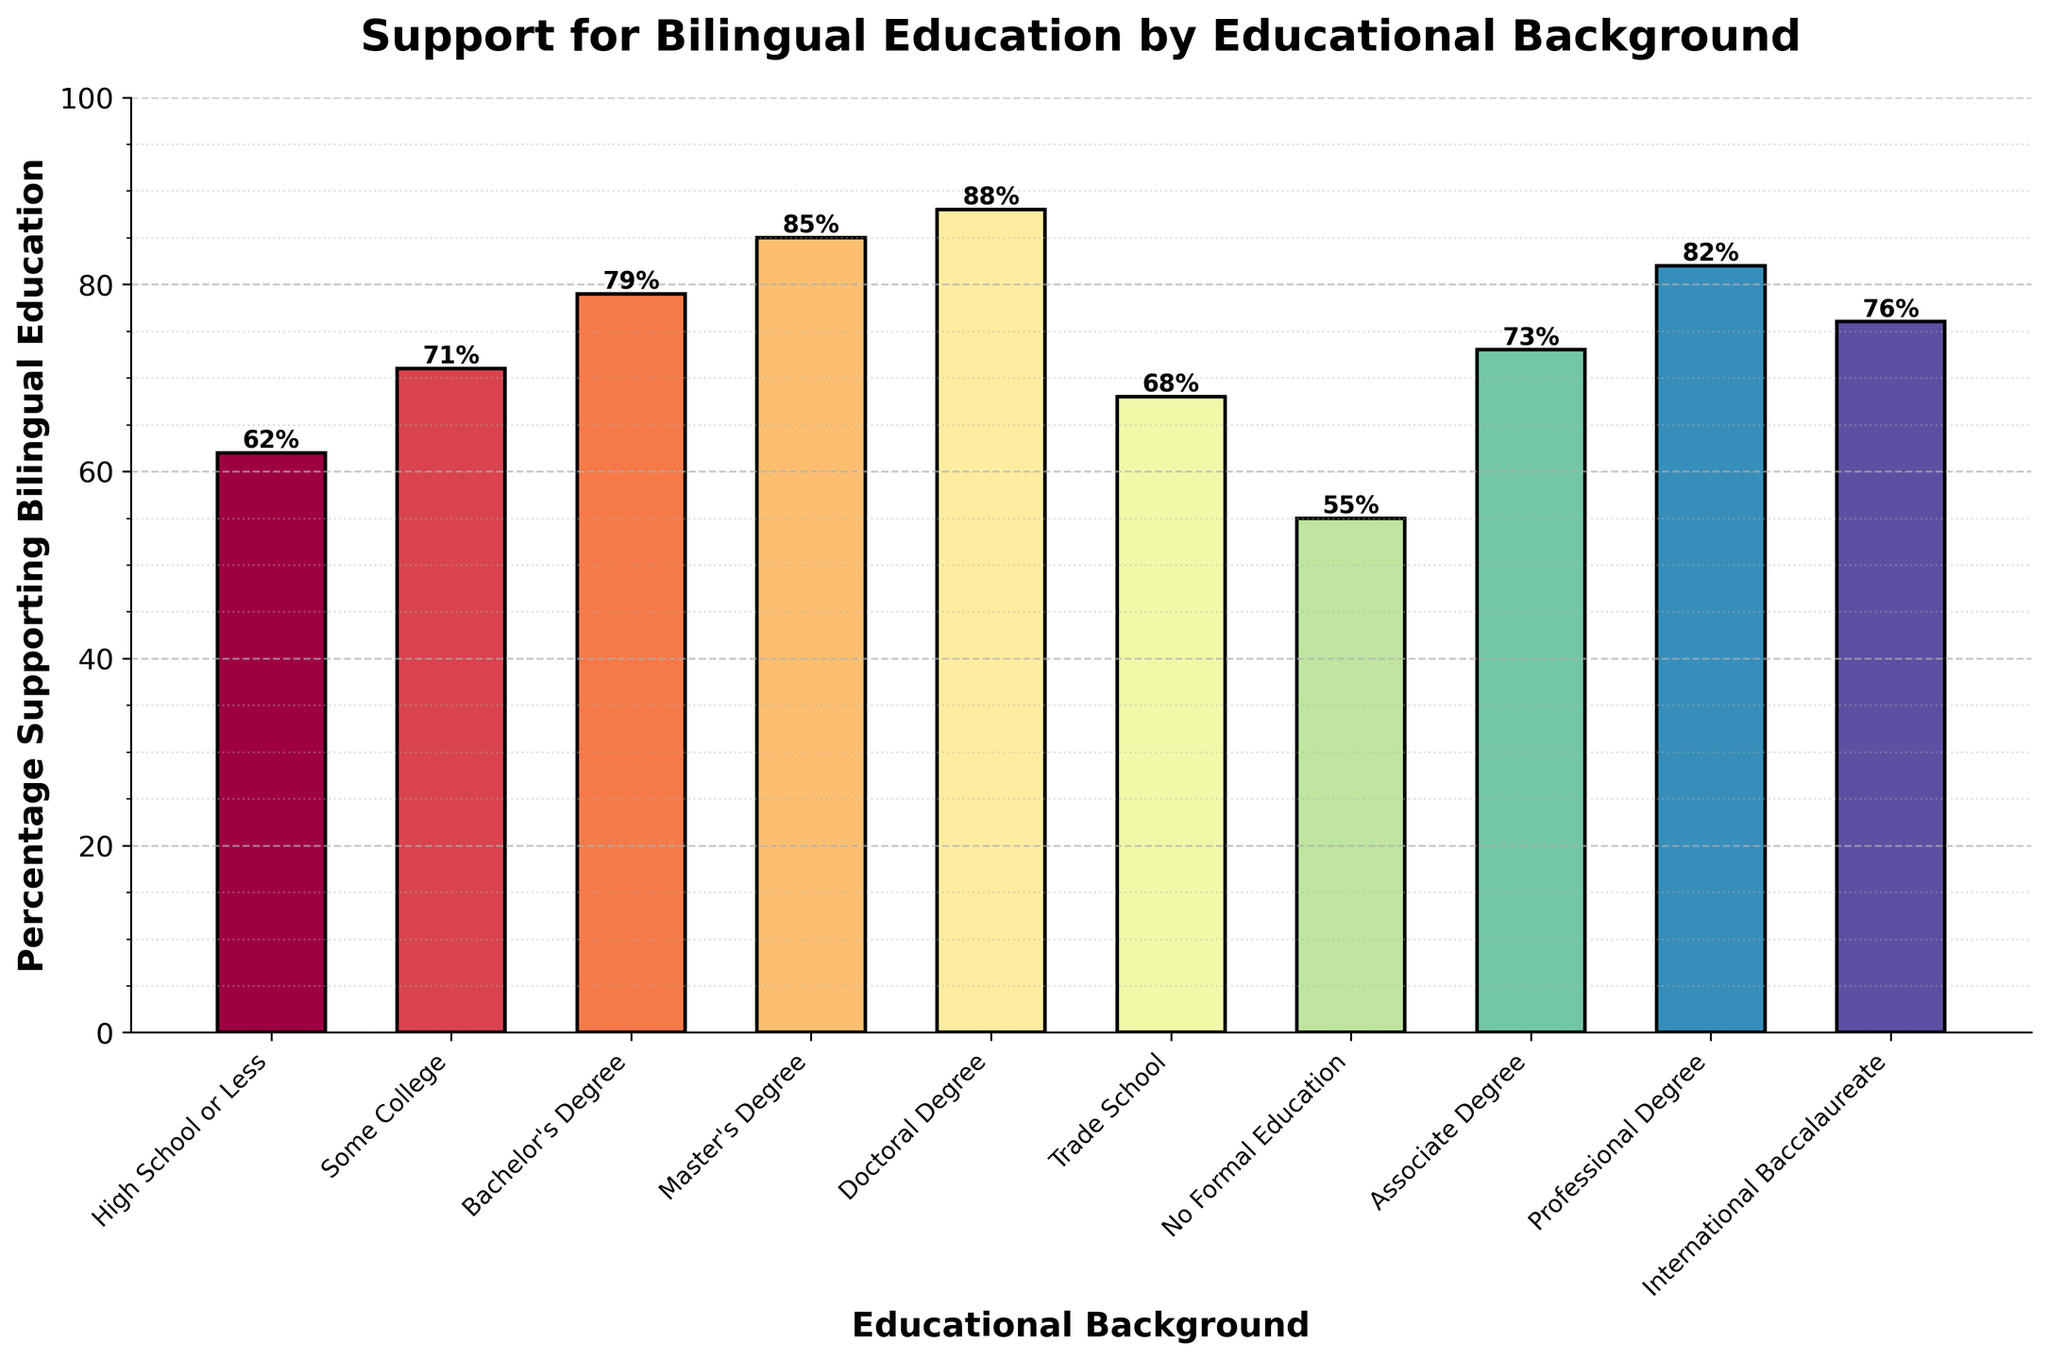What educational background shows the highest percentage of support for bilingual education? The bar representing the 'Doctoral Degree' indicates the highest value among all educational backgrounds.
Answer: Doctoral Degree Which groups have a support percentage above 80%? By visually inspecting the height of the bars and their accompanying text labels, the groups with more than 80% support are 'Master's Degree', 'Doctoral Degree', and 'Professional Degree'.
Answer: Master's Degree, Doctoral Degree, Professional Degree How much higher is the support percentage for those with a Master's Degree compared to those with No Formal Education? The support percentage for Master's Degree is 85%, and for No Formal Education is 55%. The difference is 85% - 55% = 30%.
Answer: 30% What's the average percentage of support from the groups with a Bachelor's Degree and an Associate Degree? The percentage support for a Bachelor's Degree is 79% and for an Associate Degree is 73%. The average is (79 + 73) / 2 = 76%.
Answer: 76% Do those with an International Baccalaureate or Some College have higher support for bilingual education? The percentage support for International Baccalaureate is 76%, whereas for Some College it is 71%. Comparing these two values, International Baccalaureate has higher support.
Answer: International Baccalaureate What is the range in the percentage of support between the highest and lowest educational backgrounds? The highest percentage is 88% (Doctoral Degree), and the lowest is 55% (No Formal Education). The range is 88% - 55% = 33%.
Answer: 33% Are there any educational backgrounds whose support percentage falls between 60% and 70%? From the chart, the groups falling in this range are 'High School or Less' at 62% and 'Trade School' at 68%.
Answer: High School or Less, Trade School Which group shows exactly 71% support for bilingual education? By checking the data labels in the chart, the group with 71% support is 'Some College'.
Answer: Some College Is the color of the bar representing Master's Degree darker than the one representing Trade School? Visual assessment of the bar colors shows that the color of the 'Master's Degree' bar appears darker on the color spectrum than the 'Trade School' bar.
Answer: Yes How many educational backgrounds have support percentages above the overall average? Calculate the overall average: (62 + 71 + 79 + 85 + 88 + 68 + 55 + 73 + 82 + 76) / 10 = 73.9%. The groups above this average are 'Bachelor's Degree', 'Master's Degree', 'Doctoral Degree', 'Associate Degree', 'Professional Degree', and 'International Baccalaureate' - totaling 6 groups.
Answer: 6 